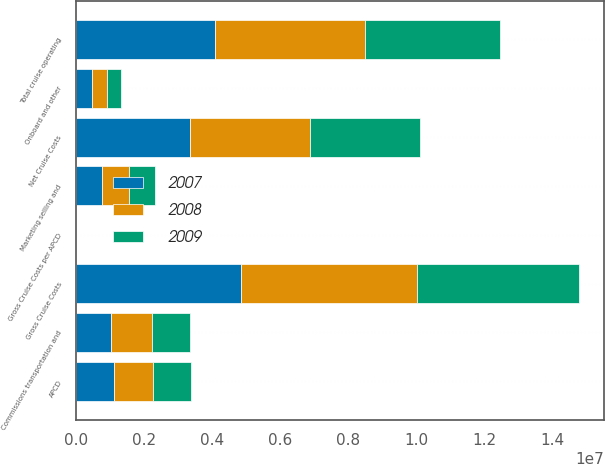<chart> <loc_0><loc_0><loc_500><loc_500><stacked_bar_chart><ecel><fcel>Total cruise operating<fcel>Marketing selling and<fcel>Gross Cruise Costs<fcel>Commissions transportation and<fcel>Onboard and other<fcel>Net Cruise Costs<fcel>APCD<fcel>Gross Cruise Costs per APCD<nl><fcel>2007<fcel>4.0711e+06<fcel>761999<fcel>4.8331e+06<fcel>1.02887e+06<fcel>457772<fcel>3.34646e+06<fcel>1.12402e+06<fcel>173.72<nl><fcel>2008<fcel>4.40367e+06<fcel>776522<fcel>5.18019e+06<fcel>1.19232e+06<fcel>458385<fcel>3.52949e+06<fcel>1.12402e+06<fcel>195.75<nl><fcel>2009<fcel>3.9817e+06<fcel>783040<fcel>4.76474e+06<fcel>1.12402e+06<fcel>405637<fcel>3.23508e+06<fcel>1.12402e+06<fcel>189.41<nl></chart> 